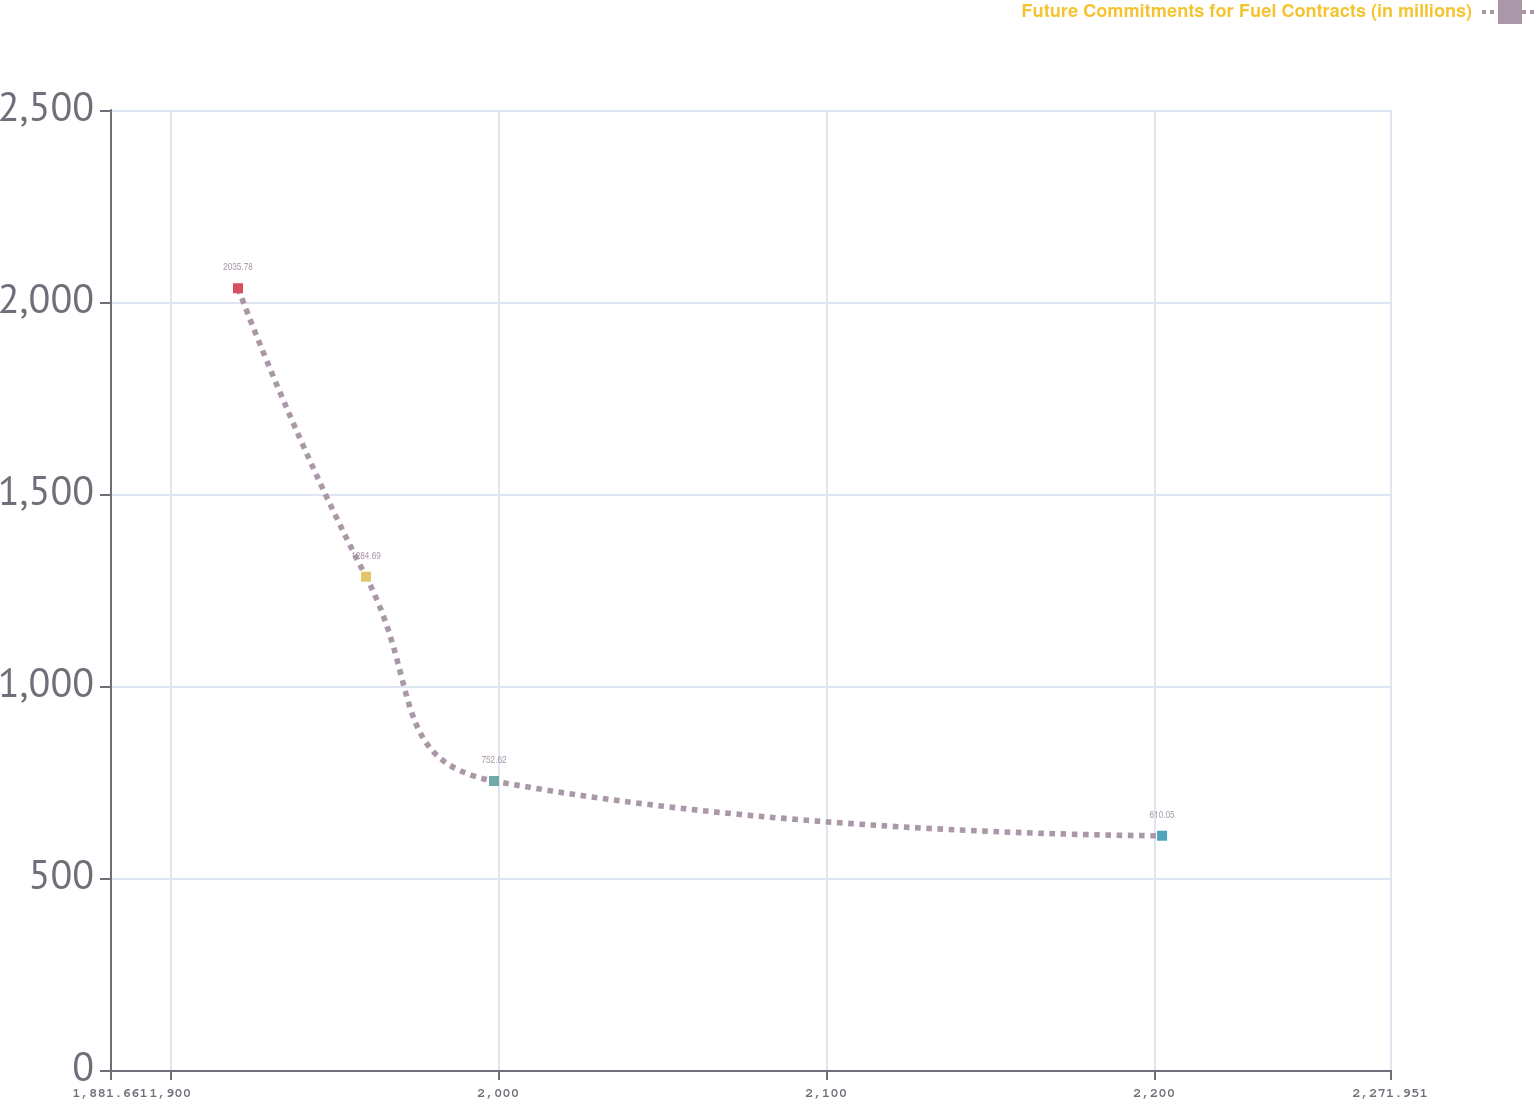Convert chart to OTSL. <chart><loc_0><loc_0><loc_500><loc_500><line_chart><ecel><fcel>Future Commitments for Fuel Contracts (in millions)<nl><fcel>1920.69<fcel>2035.78<nl><fcel>1959.72<fcel>1284.69<nl><fcel>1998.75<fcel>752.62<nl><fcel>2202.46<fcel>610.05<nl><fcel>2310.98<fcel>895.19<nl></chart> 